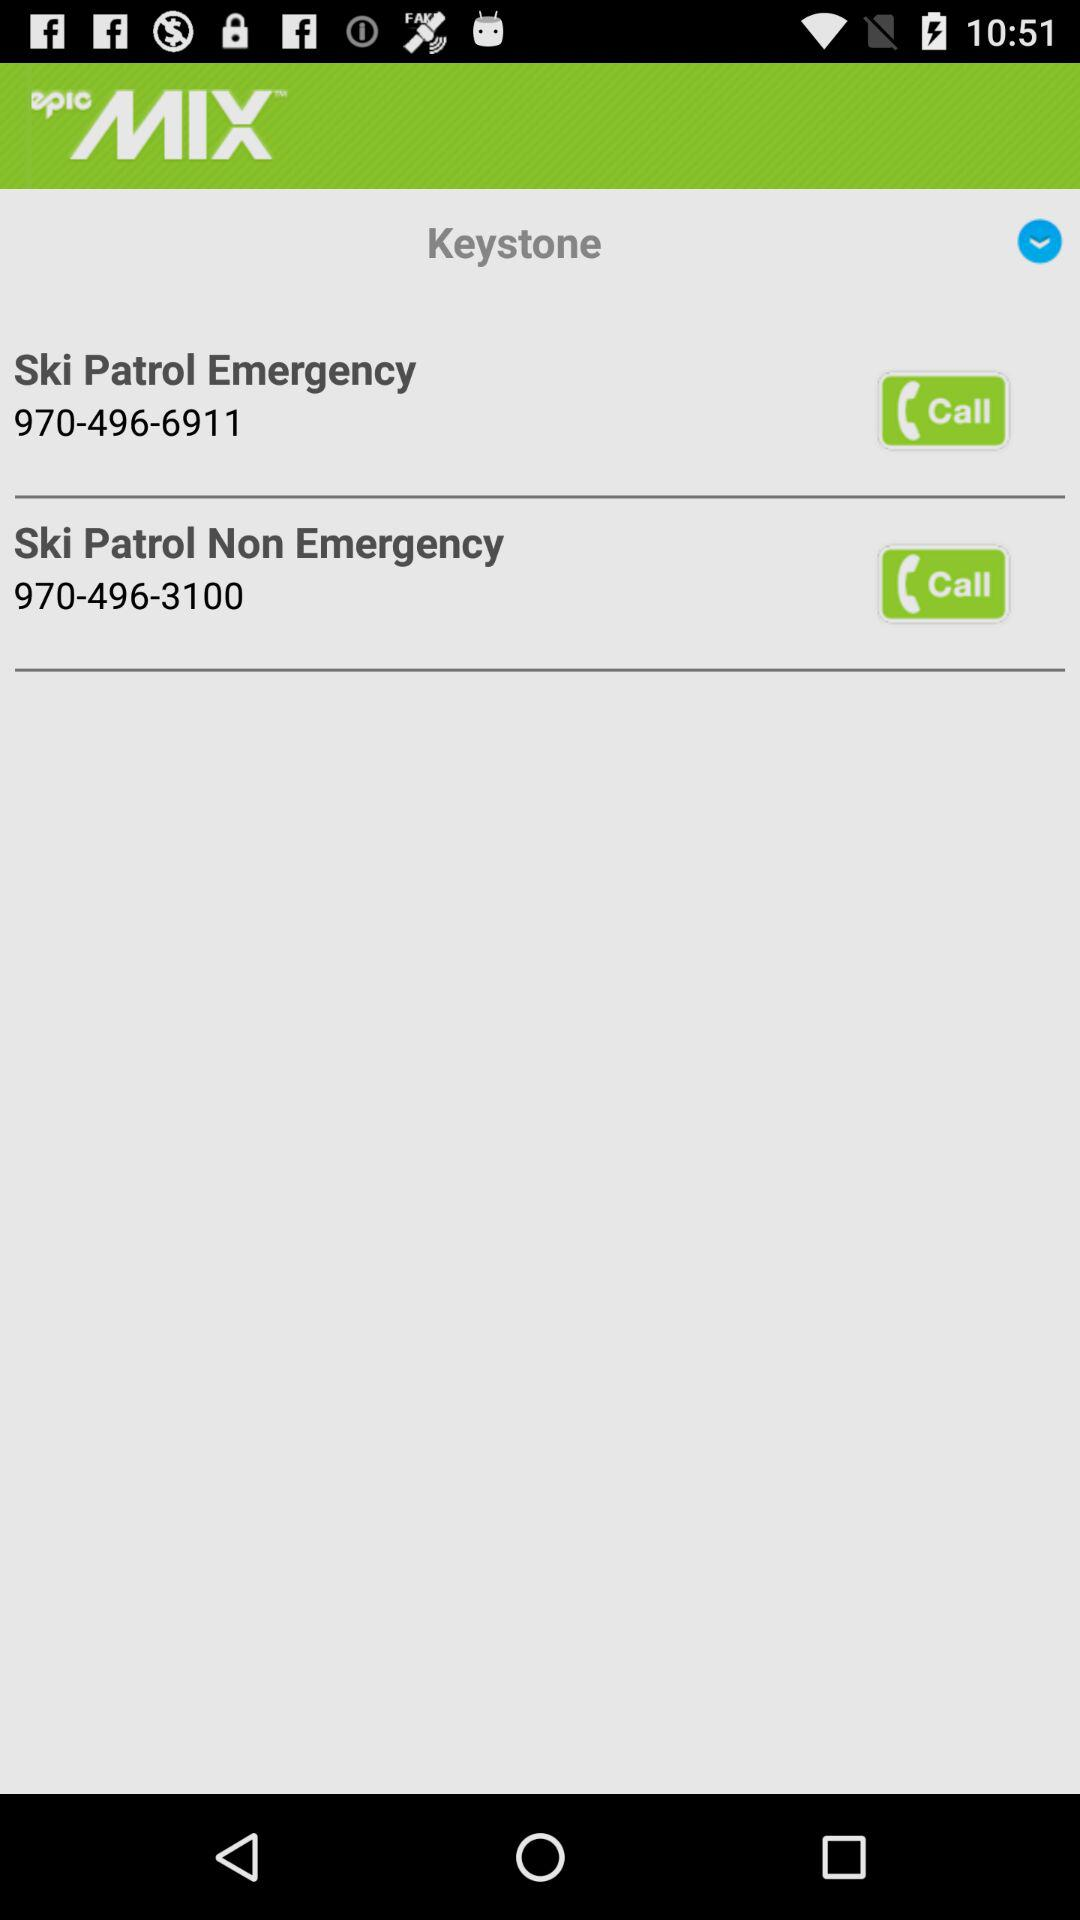What is the name of the application? The name of the application is "epicMIX". 